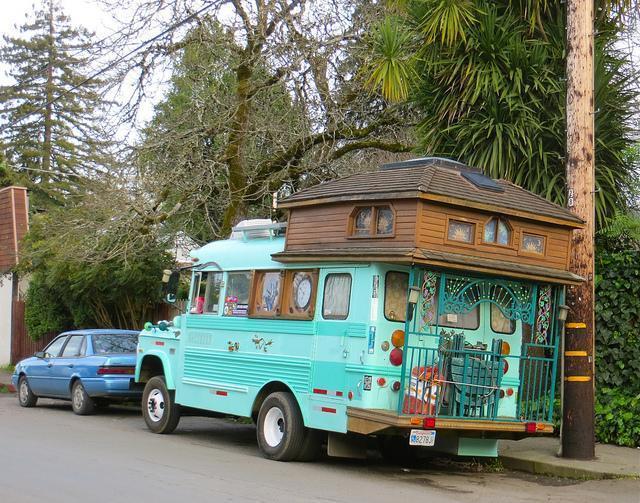How many days is this person preparing to be gone?
Give a very brief answer. 0. 